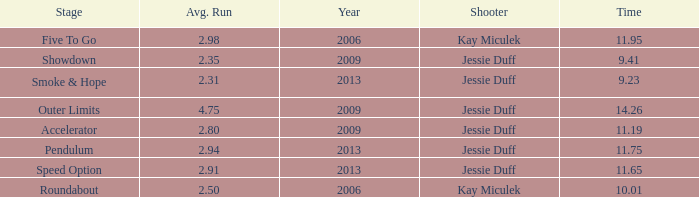What is the total amount of time for years prior to 2013 when speed option is the stage? None. 